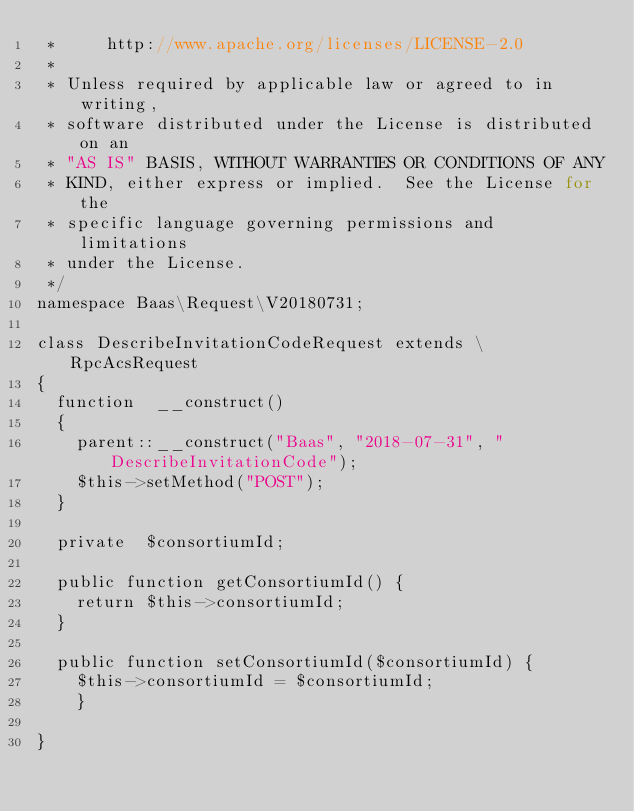<code> <loc_0><loc_0><loc_500><loc_500><_PHP_> *     http://www.apache.org/licenses/LICENSE-2.0
 *
 * Unless required by applicable law or agreed to in writing,
 * software distributed under the License is distributed on an
 * "AS IS" BASIS, WITHOUT WARRANTIES OR CONDITIONS OF ANY
 * KIND, either express or implied.  See the License for the
 * specific language governing permissions and limitations
 * under the License.
 */
namespace Baas\Request\V20180731;

class DescribeInvitationCodeRequest extends \RpcAcsRequest
{
	function  __construct()
	{
		parent::__construct("Baas", "2018-07-31", "DescribeInvitationCode");
		$this->setMethod("POST");
	}

	private  $consortiumId;

	public function getConsortiumId() {
		return $this->consortiumId;
	}

	public function setConsortiumId($consortiumId) {
		$this->consortiumId = $consortiumId;
		}
	
}</code> 